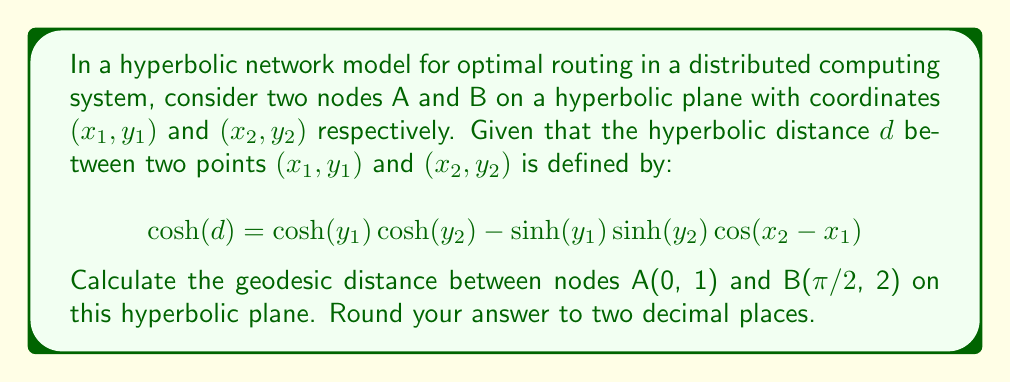Could you help me with this problem? To solve this problem, we'll follow these steps:

1) Identify the given coordinates:
   A: $(x_1, y_1) = (0, 1)$
   B: $(x_2, y_2) = (\frac{\pi}{2}, 2)$

2) Substitute these values into the hyperbolic distance formula:

   $$\cosh(d) = \cosh(1)\cosh(2) - \sinh(1)\sinh(2)\cos(\frac{\pi}{2} - 0)$$

3) Simplify:
   - $\cos(\frac{\pi}{2}) = 0$, so the second term becomes zero

   $$\cosh(d) = \cosh(1)\cosh(2)$$

4) Calculate the values:
   - $\cosh(1) \approx 1.5430806348$
   - $\cosh(2) \approx 3.7621956911$

5) Multiply:

   $$\cosh(d) = 1.5430806348 * 3.7621956911 \approx 5.8053699732$$

6) To find $d$, we need to apply the inverse hyperbolic cosine (acosh) function:

   $$d = \text{acosh}(5.8053699732)$$

7) Calculate:

   $$d \approx 2.4912659694$$

8) Round to two decimal places:

   $$d \approx 2.49$$
Answer: 2.49 